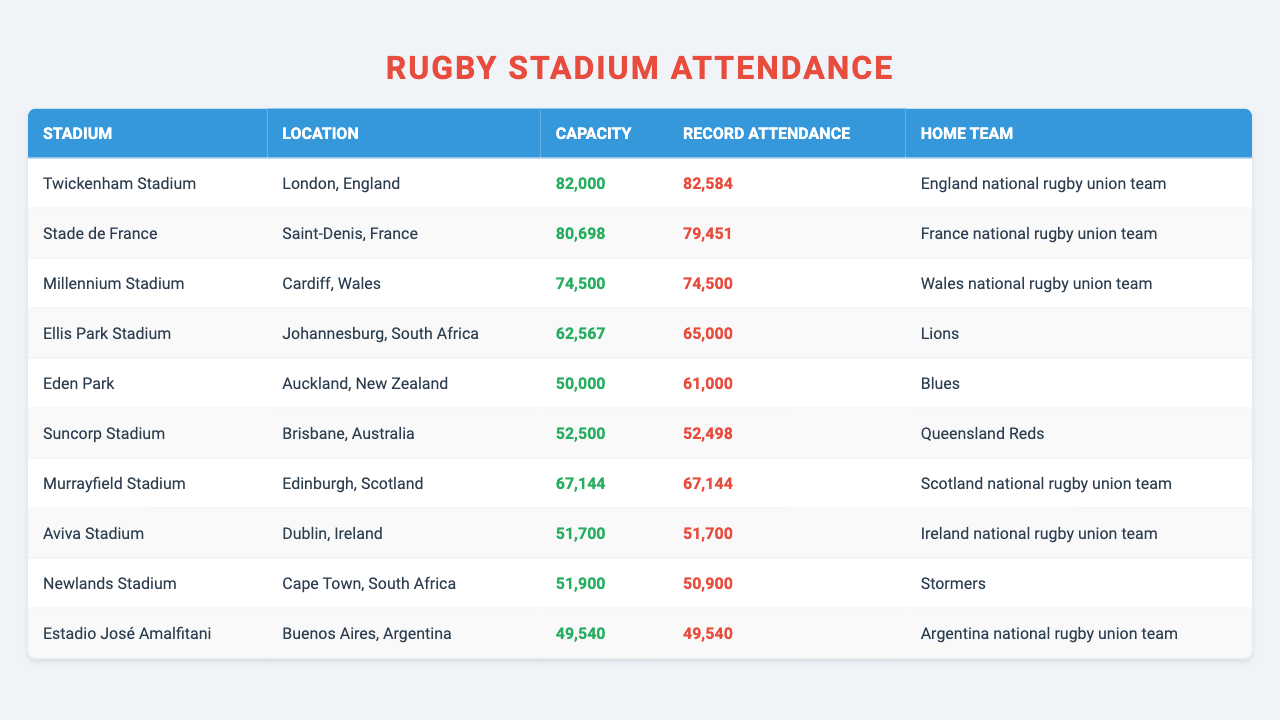What is the capacity of Twickenham Stadium? The capacity of Twickenham Stadium is shown in the table under the 'Capacity' column. It lists 82,000.
Answer: 82,000 Which stadium has the highest record attendance? The 'Record Attendance' column shows that Twickenham Stadium has the highest record attendance of 82,584.
Answer: Twickenham Stadium Is the record attendance for Eden Park greater than its capacity? The record attendance for Eden Park is listed as 61,000, which is greater than its capacity of 50,000.
Answer: Yes How many stadiums have a record attendance equal to their capacity? By reviewing the 'Record Attendance' and 'Capacity' columns, Millennium Stadium and Murrayfield Stadium show equal figures (74,500 and 67,144 respectively), making a total of 2 stadiums.
Answer: 2 What is the average capacity of the stadiums listed? First, add together all the capacities: 82,000 + 80,698 + 74,500 + 62,567 + 50,000 + 52,500 + 67,144 + 51,700 + 51,900 + 49,540 = 670,000. Then divide by the number of stadiums, which is 10, giving an average capacity of 67,000.
Answer: 67,000 Which home team has the smallest stadium capacity? The 'Home Team' and 'Capacity' columns show that the Argentina national rugby union team plays at Estadio José Amalfitani, which has the smallest capacity of 49,540.
Answer: Argentina national rugby union team How many stadiums are located in South Africa? By checking the 'Location' column, there are two stadiums listed in South Africa: Ellis Park Stadium and Newlands Stadium.
Answer: 2 Is there any stadium in the table that has a record attendance specifically lower than its capacity? By comparing the 'Record Attendance' with 'Capacity', Suncorp Stadium has a record attendance of 52,498, which is lower than its capacity of 52,500.
Answer: Yes What is the difference in record attendance between Twickenham Stadium and Stade de France? Twickenham's record attendance is 82,584, and Stade de France's is 79,451. The difference is 82,584 - 79,451 = 3,133.
Answer: 3,133 Which home team plays at the largest capacity stadium? Twickenham Stadium has the largest capacity of 82,000, and its home team is the England national rugby union team.
Answer: England national rugby union team 